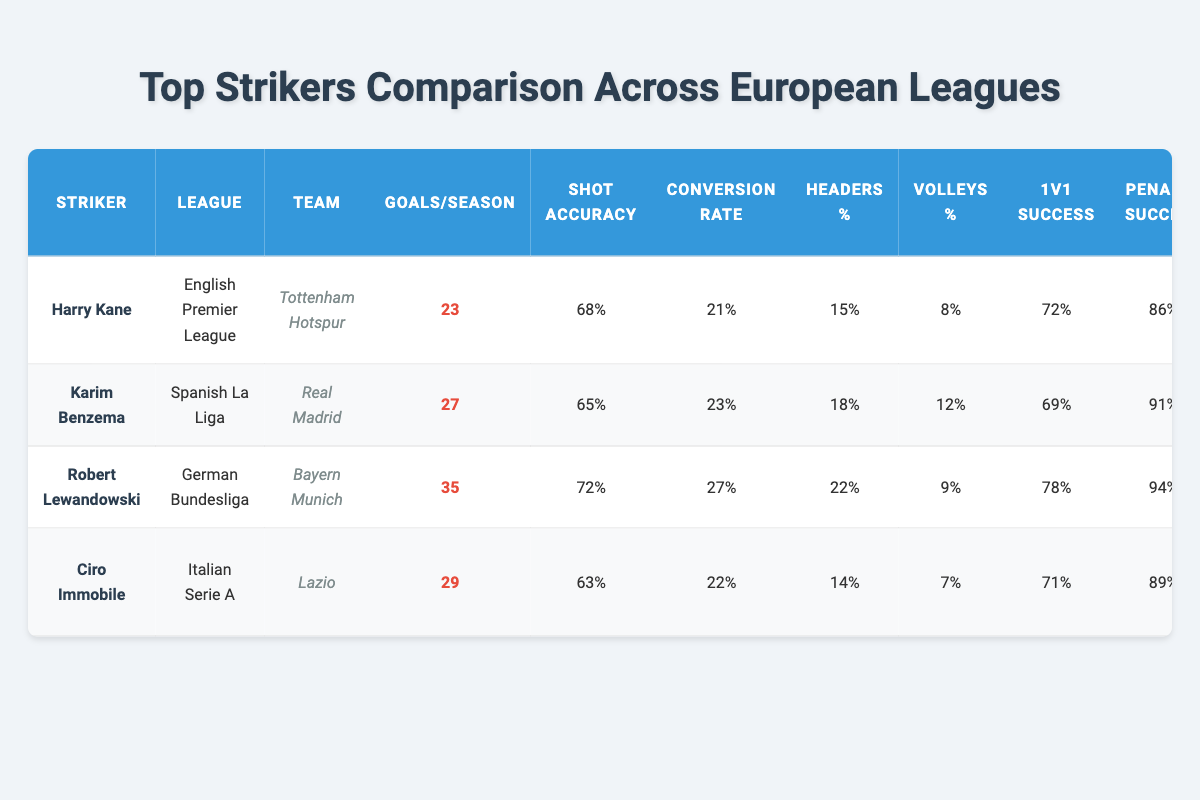What is the highest number of goals scored per season? Robert Lewandowski scored the highest with 35 goals in the German Bundesliga.
Answer: 35 Which striker has the best shot accuracy? Robert Lewandowski has the best shot accuracy at 72%.
Answer: 72% Who has the highest penalty success rate? Robert Lewandowski has the highest penalty success rate at 94%.
Answer: 94% Is Ciro Immobile's one-on-one success percentage higher than that of Harry Kane? Ciro Immobile's one-on-one success is 71%, while Harry Kane's is 72%. Therefore, it is false that Ciro's percentage is higher.
Answer: No What is the average number of free kick goals scored by the strikers? The total free kick goals are 2 (Kane) + 1 (Benzema) + 3 (Lewandowski) + 1 (Immobile) = 7. There are 4 strikers, so the average is 7/4 = 1.75.
Answer: 1.75 What is the difference in conversion rates between Karim Benzema and Harry Kane? Karim Benzema has a conversion rate of 23% and Harry Kane has 21%. The difference is 23 - 21 = 2%.
Answer: 2% Which league does the striker with the most goals belong to? Robert Lewandowski with 35 goals belongs to the German Bundesliga.
Answer: German Bundesliga Does any striker have a higher headers percentage than Robert Lewandowski? Robert Lewandowski has a headers percentage of 22%, and Ciro Immobile has 14%, Harry Kane has 15%, and Karim Benzema has 18%. Therefore, there are no strikers with a higher percentage.
Answer: No Which striker assisted by a veteran has the highest goals per season? Robert Lewandowski, assisted by Thomas Müller, has the highest goals per season at 35.
Answer: 35 